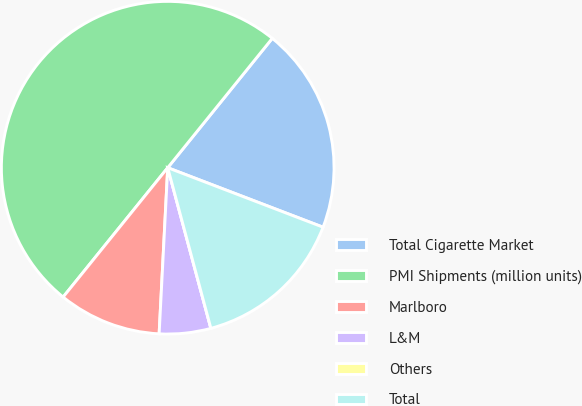Convert chart to OTSL. <chart><loc_0><loc_0><loc_500><loc_500><pie_chart><fcel>Total Cigarette Market<fcel>PMI Shipments (million units)<fcel>Marlboro<fcel>L&M<fcel>Others<fcel>Total<nl><fcel>20.0%<fcel>49.99%<fcel>10.0%<fcel>5.0%<fcel>0.0%<fcel>15.0%<nl></chart> 